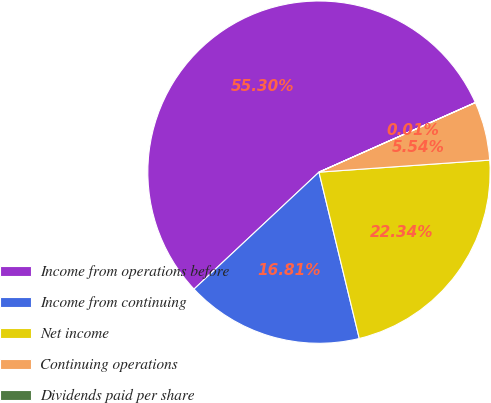Convert chart to OTSL. <chart><loc_0><loc_0><loc_500><loc_500><pie_chart><fcel>Income from operations before<fcel>Income from continuing<fcel>Net income<fcel>Continuing operations<fcel>Dividends paid per share<nl><fcel>55.31%<fcel>16.81%<fcel>22.34%<fcel>5.54%<fcel>0.01%<nl></chart> 